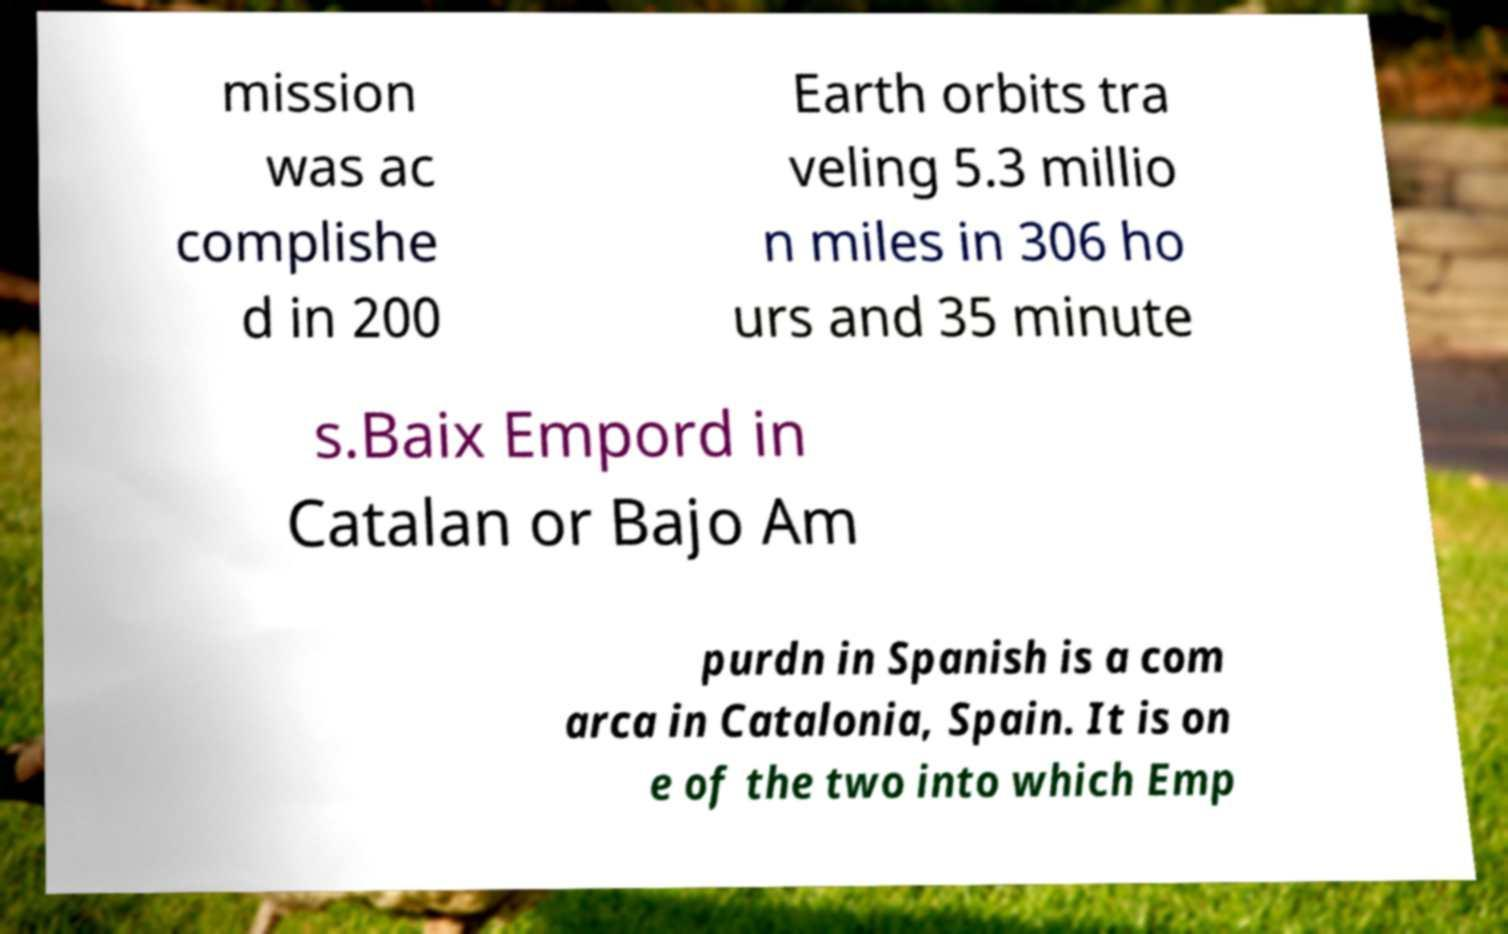Can you accurately transcribe the text from the provided image for me? mission was ac complishe d in 200 Earth orbits tra veling 5.3 millio n miles in 306 ho urs and 35 minute s.Baix Empord in Catalan or Bajo Am purdn in Spanish is a com arca in Catalonia, Spain. It is on e of the two into which Emp 